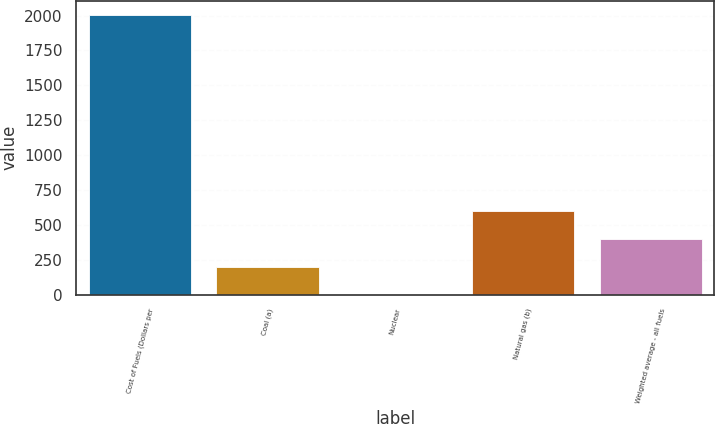Convert chart. <chart><loc_0><loc_0><loc_500><loc_500><bar_chart><fcel>Cost of Fuels (Dollars per<fcel>Coal (a)<fcel>Nuclear<fcel>Natural gas (b)<fcel>Weighted average - all fuels<nl><fcel>2007<fcel>201.14<fcel>0.49<fcel>602.44<fcel>401.79<nl></chart> 